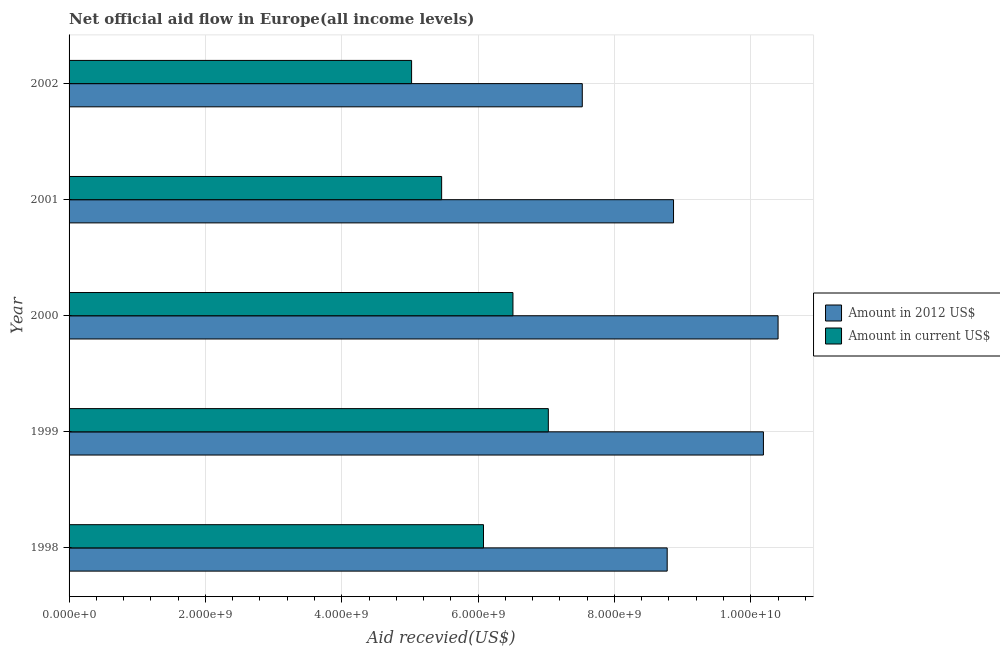Are the number of bars per tick equal to the number of legend labels?
Offer a very short reply. Yes. Are the number of bars on each tick of the Y-axis equal?
Ensure brevity in your answer.  Yes. How many bars are there on the 2nd tick from the top?
Your answer should be compact. 2. What is the label of the 5th group of bars from the top?
Your answer should be compact. 1998. In how many cases, is the number of bars for a given year not equal to the number of legend labels?
Your answer should be compact. 0. What is the amount of aid received(expressed in 2012 us$) in 2002?
Your answer should be very brief. 7.53e+09. Across all years, what is the maximum amount of aid received(expressed in 2012 us$)?
Keep it short and to the point. 1.04e+1. Across all years, what is the minimum amount of aid received(expressed in 2012 us$)?
Give a very brief answer. 7.53e+09. In which year was the amount of aid received(expressed in us$) minimum?
Your response must be concise. 2002. What is the total amount of aid received(expressed in us$) in the graph?
Your answer should be compact. 3.01e+1. What is the difference between the amount of aid received(expressed in us$) in 1998 and that in 2000?
Your answer should be compact. -4.32e+08. What is the difference between the amount of aid received(expressed in us$) in 1999 and the amount of aid received(expressed in 2012 us$) in 2002?
Give a very brief answer. -4.98e+08. What is the average amount of aid received(expressed in 2012 us$) per year?
Provide a succinct answer. 9.15e+09. In the year 1998, what is the difference between the amount of aid received(expressed in 2012 us$) and amount of aid received(expressed in us$)?
Your response must be concise. 2.69e+09. In how many years, is the amount of aid received(expressed in us$) greater than 800000000 US$?
Your answer should be compact. 5. What is the ratio of the amount of aid received(expressed in 2012 us$) in 1999 to that in 2001?
Offer a very short reply. 1.15. Is the amount of aid received(expressed in 2012 us$) in 2000 less than that in 2001?
Offer a terse response. No. What is the difference between the highest and the second highest amount of aid received(expressed in us$)?
Provide a short and direct response. 5.19e+08. What is the difference between the highest and the lowest amount of aid received(expressed in us$)?
Make the answer very short. 2.01e+09. In how many years, is the amount of aid received(expressed in us$) greater than the average amount of aid received(expressed in us$) taken over all years?
Give a very brief answer. 3. Is the sum of the amount of aid received(expressed in us$) in 2001 and 2002 greater than the maximum amount of aid received(expressed in 2012 us$) across all years?
Ensure brevity in your answer.  Yes. What does the 2nd bar from the top in 1999 represents?
Provide a succinct answer. Amount in 2012 US$. What does the 2nd bar from the bottom in 1999 represents?
Your answer should be very brief. Amount in current US$. How many bars are there?
Offer a very short reply. 10. Are all the bars in the graph horizontal?
Your answer should be very brief. Yes. How many years are there in the graph?
Keep it short and to the point. 5. What is the difference between two consecutive major ticks on the X-axis?
Offer a very short reply. 2.00e+09. Does the graph contain any zero values?
Offer a terse response. No. How many legend labels are there?
Make the answer very short. 2. How are the legend labels stacked?
Your answer should be compact. Vertical. What is the title of the graph?
Ensure brevity in your answer.  Net official aid flow in Europe(all income levels). What is the label or title of the X-axis?
Provide a succinct answer. Aid recevied(US$). What is the label or title of the Y-axis?
Make the answer very short. Year. What is the Aid recevied(US$) of Amount in 2012 US$ in 1998?
Your response must be concise. 8.77e+09. What is the Aid recevied(US$) in Amount in current US$ in 1998?
Give a very brief answer. 6.08e+09. What is the Aid recevied(US$) in Amount in 2012 US$ in 1999?
Your answer should be very brief. 1.02e+1. What is the Aid recevied(US$) of Amount in current US$ in 1999?
Make the answer very short. 7.03e+09. What is the Aid recevied(US$) in Amount in 2012 US$ in 2000?
Your response must be concise. 1.04e+1. What is the Aid recevied(US$) in Amount in current US$ in 2000?
Make the answer very short. 6.51e+09. What is the Aid recevied(US$) in Amount in 2012 US$ in 2001?
Your answer should be compact. 8.87e+09. What is the Aid recevied(US$) in Amount in current US$ in 2001?
Your answer should be compact. 5.47e+09. What is the Aid recevied(US$) of Amount in 2012 US$ in 2002?
Your response must be concise. 7.53e+09. What is the Aid recevied(US$) in Amount in current US$ in 2002?
Your response must be concise. 5.02e+09. Across all years, what is the maximum Aid recevied(US$) of Amount in 2012 US$?
Provide a short and direct response. 1.04e+1. Across all years, what is the maximum Aid recevied(US$) of Amount in current US$?
Your answer should be very brief. 7.03e+09. Across all years, what is the minimum Aid recevied(US$) of Amount in 2012 US$?
Keep it short and to the point. 7.53e+09. Across all years, what is the minimum Aid recevied(US$) of Amount in current US$?
Your response must be concise. 5.02e+09. What is the total Aid recevied(US$) of Amount in 2012 US$ in the graph?
Your response must be concise. 4.58e+1. What is the total Aid recevied(US$) in Amount in current US$ in the graph?
Provide a succinct answer. 3.01e+1. What is the difference between the Aid recevied(US$) in Amount in 2012 US$ in 1998 and that in 1999?
Provide a succinct answer. -1.41e+09. What is the difference between the Aid recevied(US$) of Amount in current US$ in 1998 and that in 1999?
Keep it short and to the point. -9.51e+08. What is the difference between the Aid recevied(US$) in Amount in 2012 US$ in 1998 and that in 2000?
Provide a succinct answer. -1.63e+09. What is the difference between the Aid recevied(US$) in Amount in current US$ in 1998 and that in 2000?
Your response must be concise. -4.32e+08. What is the difference between the Aid recevied(US$) of Amount in 2012 US$ in 1998 and that in 2001?
Keep it short and to the point. -9.31e+07. What is the difference between the Aid recevied(US$) in Amount in current US$ in 1998 and that in 2001?
Provide a short and direct response. 6.14e+08. What is the difference between the Aid recevied(US$) in Amount in 2012 US$ in 1998 and that in 2002?
Give a very brief answer. 1.25e+09. What is the difference between the Aid recevied(US$) of Amount in current US$ in 1998 and that in 2002?
Your answer should be very brief. 1.05e+09. What is the difference between the Aid recevied(US$) of Amount in 2012 US$ in 1999 and that in 2000?
Give a very brief answer. -2.15e+08. What is the difference between the Aid recevied(US$) in Amount in current US$ in 1999 and that in 2000?
Ensure brevity in your answer.  5.19e+08. What is the difference between the Aid recevied(US$) in Amount in 2012 US$ in 1999 and that in 2001?
Offer a terse response. 1.32e+09. What is the difference between the Aid recevied(US$) in Amount in current US$ in 1999 and that in 2001?
Ensure brevity in your answer.  1.57e+09. What is the difference between the Aid recevied(US$) of Amount in 2012 US$ in 1999 and that in 2002?
Offer a terse response. 2.66e+09. What is the difference between the Aid recevied(US$) of Amount in current US$ in 1999 and that in 2002?
Provide a succinct answer. 2.01e+09. What is the difference between the Aid recevied(US$) of Amount in 2012 US$ in 2000 and that in 2001?
Your response must be concise. 1.53e+09. What is the difference between the Aid recevied(US$) of Amount in current US$ in 2000 and that in 2001?
Your response must be concise. 1.05e+09. What is the difference between the Aid recevied(US$) of Amount in 2012 US$ in 2000 and that in 2002?
Your answer should be compact. 2.87e+09. What is the difference between the Aid recevied(US$) of Amount in current US$ in 2000 and that in 2002?
Your response must be concise. 1.49e+09. What is the difference between the Aid recevied(US$) of Amount in 2012 US$ in 2001 and that in 2002?
Provide a short and direct response. 1.34e+09. What is the difference between the Aid recevied(US$) of Amount in current US$ in 2001 and that in 2002?
Offer a very short reply. 4.41e+08. What is the difference between the Aid recevied(US$) in Amount in 2012 US$ in 1998 and the Aid recevied(US$) in Amount in current US$ in 1999?
Give a very brief answer. 1.74e+09. What is the difference between the Aid recevied(US$) of Amount in 2012 US$ in 1998 and the Aid recevied(US$) of Amount in current US$ in 2000?
Make the answer very short. 2.26e+09. What is the difference between the Aid recevied(US$) of Amount in 2012 US$ in 1998 and the Aid recevied(US$) of Amount in current US$ in 2001?
Make the answer very short. 3.31e+09. What is the difference between the Aid recevied(US$) in Amount in 2012 US$ in 1998 and the Aid recevied(US$) in Amount in current US$ in 2002?
Provide a succinct answer. 3.75e+09. What is the difference between the Aid recevied(US$) of Amount in 2012 US$ in 1999 and the Aid recevied(US$) of Amount in current US$ in 2000?
Give a very brief answer. 3.67e+09. What is the difference between the Aid recevied(US$) in Amount in 2012 US$ in 1999 and the Aid recevied(US$) in Amount in current US$ in 2001?
Ensure brevity in your answer.  4.72e+09. What is the difference between the Aid recevied(US$) of Amount in 2012 US$ in 1999 and the Aid recevied(US$) of Amount in current US$ in 2002?
Give a very brief answer. 5.16e+09. What is the difference between the Aid recevied(US$) in Amount in 2012 US$ in 2000 and the Aid recevied(US$) in Amount in current US$ in 2001?
Your response must be concise. 4.94e+09. What is the difference between the Aid recevied(US$) in Amount in 2012 US$ in 2000 and the Aid recevied(US$) in Amount in current US$ in 2002?
Keep it short and to the point. 5.38e+09. What is the difference between the Aid recevied(US$) in Amount in 2012 US$ in 2001 and the Aid recevied(US$) in Amount in current US$ in 2002?
Provide a succinct answer. 3.84e+09. What is the average Aid recevied(US$) in Amount in 2012 US$ per year?
Your response must be concise. 9.15e+09. What is the average Aid recevied(US$) of Amount in current US$ per year?
Provide a succinct answer. 6.02e+09. In the year 1998, what is the difference between the Aid recevied(US$) in Amount in 2012 US$ and Aid recevied(US$) in Amount in current US$?
Your answer should be compact. 2.69e+09. In the year 1999, what is the difference between the Aid recevied(US$) of Amount in 2012 US$ and Aid recevied(US$) of Amount in current US$?
Your answer should be very brief. 3.16e+09. In the year 2000, what is the difference between the Aid recevied(US$) of Amount in 2012 US$ and Aid recevied(US$) of Amount in current US$?
Offer a terse response. 3.89e+09. In the year 2001, what is the difference between the Aid recevied(US$) of Amount in 2012 US$ and Aid recevied(US$) of Amount in current US$?
Make the answer very short. 3.40e+09. In the year 2002, what is the difference between the Aid recevied(US$) of Amount in 2012 US$ and Aid recevied(US$) of Amount in current US$?
Your response must be concise. 2.50e+09. What is the ratio of the Aid recevied(US$) of Amount in 2012 US$ in 1998 to that in 1999?
Your answer should be compact. 0.86. What is the ratio of the Aid recevied(US$) in Amount in current US$ in 1998 to that in 1999?
Provide a succinct answer. 0.86. What is the ratio of the Aid recevied(US$) of Amount in 2012 US$ in 1998 to that in 2000?
Your response must be concise. 0.84. What is the ratio of the Aid recevied(US$) in Amount in current US$ in 1998 to that in 2000?
Keep it short and to the point. 0.93. What is the ratio of the Aid recevied(US$) of Amount in 2012 US$ in 1998 to that in 2001?
Make the answer very short. 0.99. What is the ratio of the Aid recevied(US$) of Amount in current US$ in 1998 to that in 2001?
Provide a succinct answer. 1.11. What is the ratio of the Aid recevied(US$) of Amount in 2012 US$ in 1998 to that in 2002?
Give a very brief answer. 1.17. What is the ratio of the Aid recevied(US$) of Amount in current US$ in 1998 to that in 2002?
Give a very brief answer. 1.21. What is the ratio of the Aid recevied(US$) of Amount in 2012 US$ in 1999 to that in 2000?
Make the answer very short. 0.98. What is the ratio of the Aid recevied(US$) in Amount in current US$ in 1999 to that in 2000?
Offer a terse response. 1.08. What is the ratio of the Aid recevied(US$) in Amount in 2012 US$ in 1999 to that in 2001?
Your answer should be compact. 1.15. What is the ratio of the Aid recevied(US$) in Amount in current US$ in 1999 to that in 2001?
Your answer should be very brief. 1.29. What is the ratio of the Aid recevied(US$) in Amount in 2012 US$ in 1999 to that in 2002?
Your answer should be very brief. 1.35. What is the ratio of the Aid recevied(US$) of Amount in current US$ in 1999 to that in 2002?
Ensure brevity in your answer.  1.4. What is the ratio of the Aid recevied(US$) of Amount in 2012 US$ in 2000 to that in 2001?
Offer a very short reply. 1.17. What is the ratio of the Aid recevied(US$) of Amount in current US$ in 2000 to that in 2001?
Keep it short and to the point. 1.19. What is the ratio of the Aid recevied(US$) in Amount in 2012 US$ in 2000 to that in 2002?
Offer a very short reply. 1.38. What is the ratio of the Aid recevied(US$) of Amount in current US$ in 2000 to that in 2002?
Your answer should be very brief. 1.3. What is the ratio of the Aid recevied(US$) of Amount in 2012 US$ in 2001 to that in 2002?
Give a very brief answer. 1.18. What is the ratio of the Aid recevied(US$) of Amount in current US$ in 2001 to that in 2002?
Provide a succinct answer. 1.09. What is the difference between the highest and the second highest Aid recevied(US$) of Amount in 2012 US$?
Provide a short and direct response. 2.15e+08. What is the difference between the highest and the second highest Aid recevied(US$) of Amount in current US$?
Offer a terse response. 5.19e+08. What is the difference between the highest and the lowest Aid recevied(US$) of Amount in 2012 US$?
Your response must be concise. 2.87e+09. What is the difference between the highest and the lowest Aid recevied(US$) in Amount in current US$?
Provide a short and direct response. 2.01e+09. 